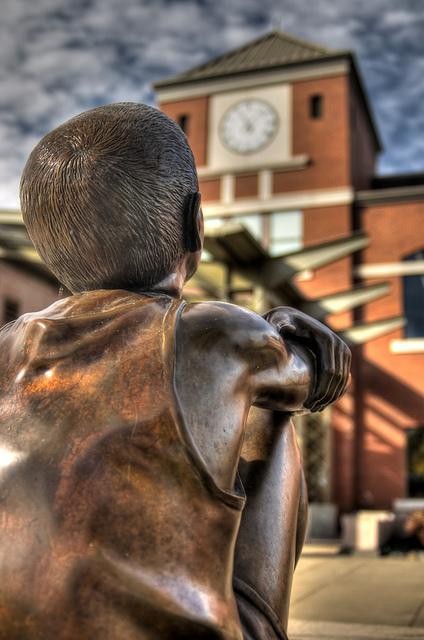Is this a statue?
Give a very brief answer. Yes. What is out of focus in this picture?
Short answer required. Building. Is this a boy sitting down?
Keep it brief. Yes. 